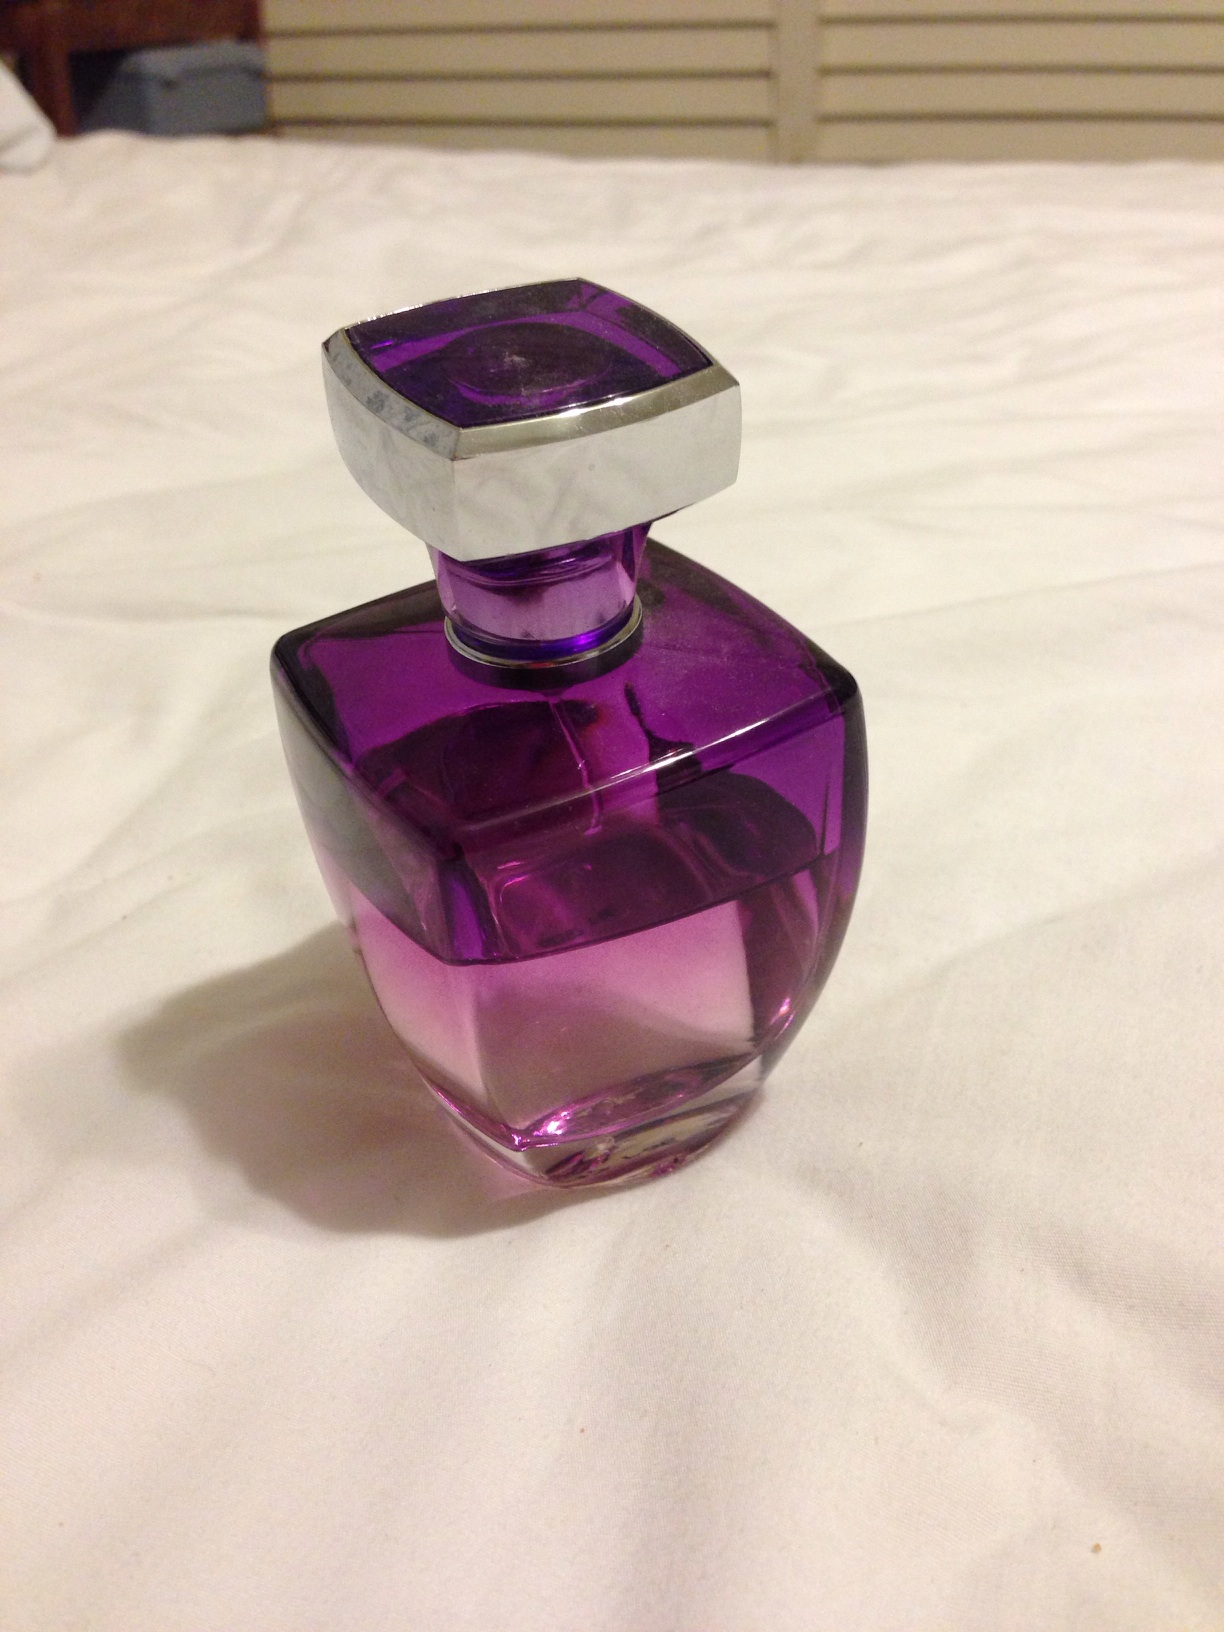What kind of setting would this perfume be suitable for? Given its classy design and the luxurious aesthetic of the bottle, this perfume might be most suitable for formal occasions or evening events, complementing a sophisticated attire and setting the tone for a memorable impression. 